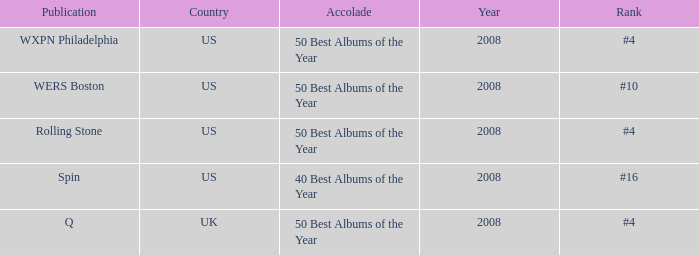For which year was the united states' ranking #4? 2008, 2008. 